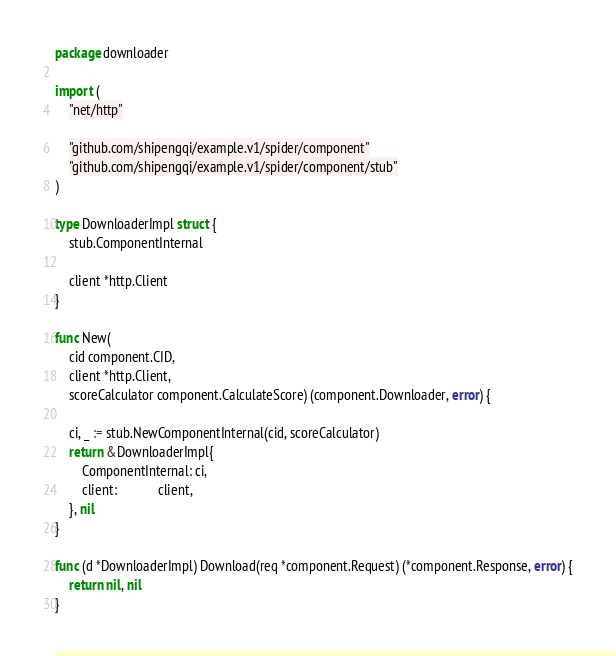<code> <loc_0><loc_0><loc_500><loc_500><_Go_>package downloader

import (
	"net/http"

	"github.com/shipengqi/example.v1/spider/component"
	"github.com/shipengqi/example.v1/spider/component/stub"
)

type DownloaderImpl struct {
	stub.ComponentInternal

	client *http.Client
}

func New(
	cid component.CID,
	client *http.Client,
	scoreCalculator component.CalculateScore) (component.Downloader, error) {

	ci, _ := stub.NewComponentInternal(cid, scoreCalculator)
	return &DownloaderImpl{
		ComponentInternal: ci,
		client:            client,
	}, nil
}

func (d *DownloaderImpl) Download(req *component.Request) (*component.Response, error) {
	return nil, nil
}
</code> 